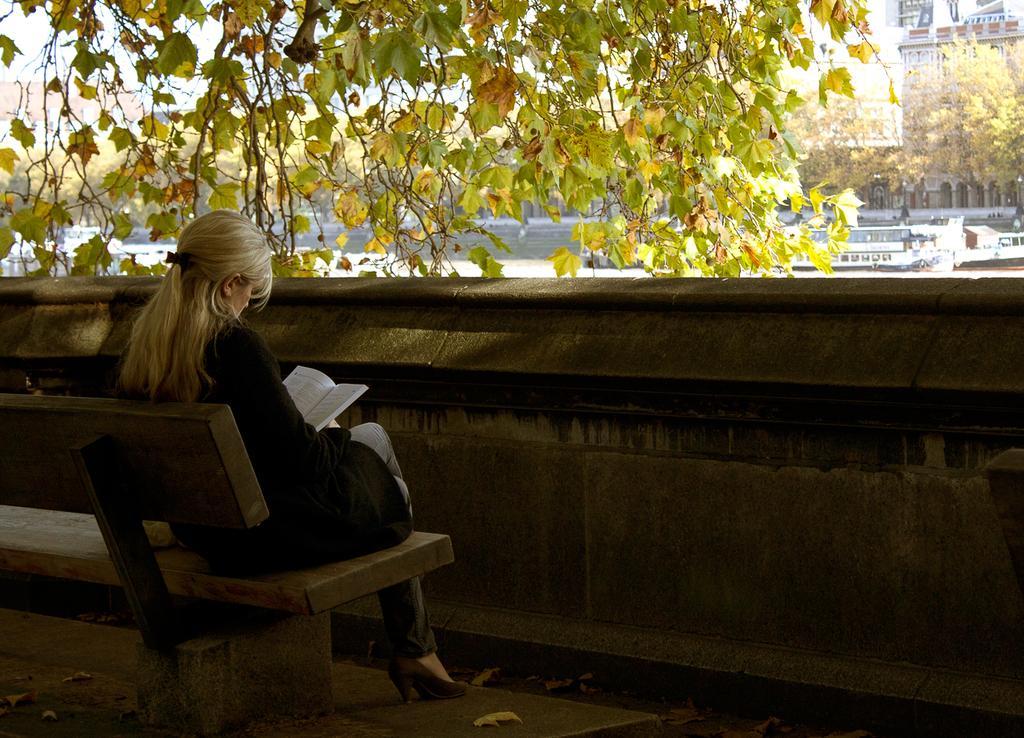Describe this image in one or two sentences. A woman is reading a book sitting on a bench beside a barrier wall. 